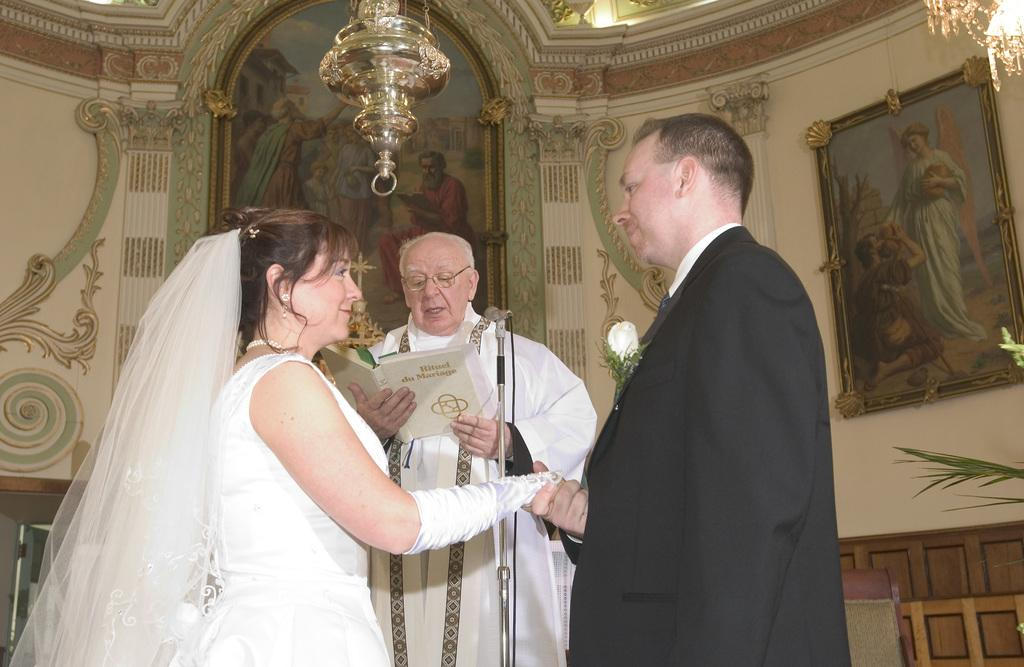What type of location might the image have been taken in? The image might have been taken in a church. How many people are present in the image? There are three people in the image: one woman and two men. What objects can be seen in the image? There are many photo frames in the image. Where is the light coming from in the image? There is light at the top of the image. What type of chalk is being used by the authority in the image? There is no chalk or authority figure present in the image. 